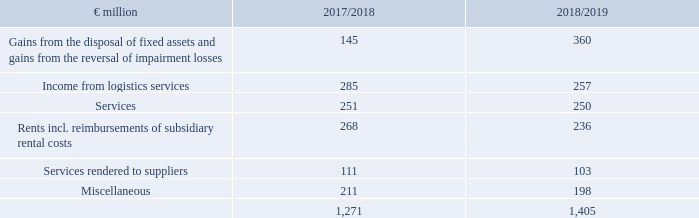2. Other operating income
Gains from the disposal of fixed assets and gains from the reversal of impairment losses includes €354 million of income from the disposal of real estates (2017/18: €137 million) and €5 million of income from reversal of impairment losses (2017/18: €4 million). Project developments and sale-and-leaseback transactions contributed to the real estate transactions.
The income from logistics services provided by METRO LOGISTICS to companies intended for disposal and non-group companies is offset by expenses from logistics services, which are reported under other operating expenses.
The other operating income includes cost allocations and cost shares as well as a great number of insignificant individual items.
Disclosures on companies intended for sale can be found under no. 43 – discontinued business sectors page 266 .
What does the other operating income include? Cost allocations and cost shares as well as a great number of insignificant individual items. What is offset by expenses from logistic services? The income from logistics services provided by metro logistics to companies intended for disposal and non-group companies. What are the components of Gains from the disposal of fixed assets and gains from the reversal of impairment losses? Income from the disposal of real estates, income from reversal of impairment losses. In which year was the amount of Services larger? 251>250
Answer: 2017/2018. What was the change in Miscellaneous in 2018/2019 from 2017/2018?
Answer scale should be: million. 198-211
Answer: -13. What was the percentage change in Miscellaneous in  2018/2019 from 2017/2018?
Answer scale should be: percent. (198-211)/211
Answer: -6.16. 